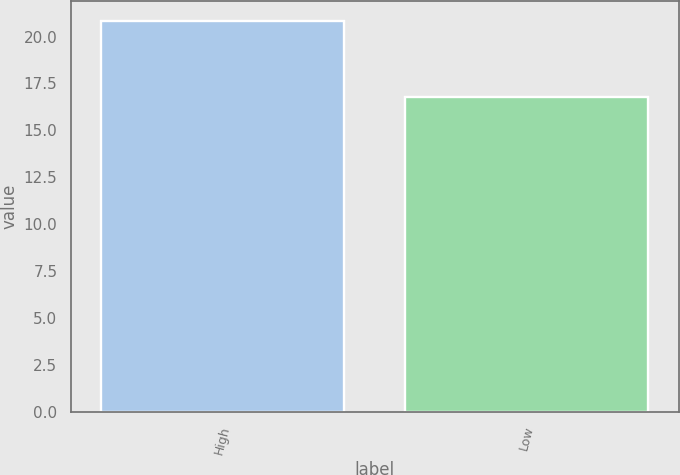Convert chart to OTSL. <chart><loc_0><loc_0><loc_500><loc_500><bar_chart><fcel>High<fcel>Low<nl><fcel>20.85<fcel>16.75<nl></chart> 